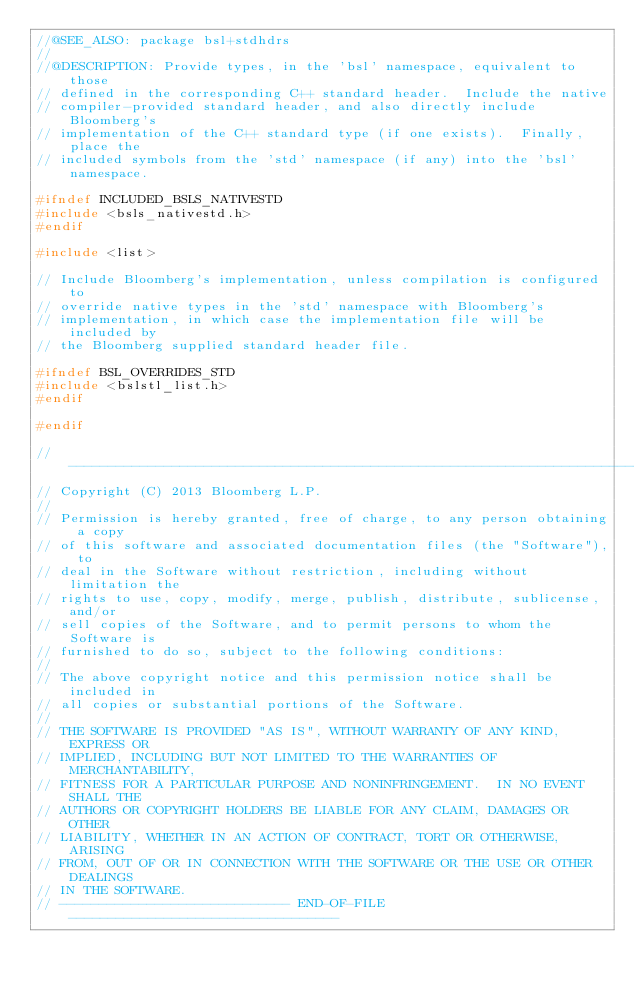<code> <loc_0><loc_0><loc_500><loc_500><_C_>//@SEE_ALSO: package bsl+stdhdrs
//
//@DESCRIPTION: Provide types, in the 'bsl' namespace, equivalent to those
// defined in the corresponding C++ standard header.  Include the native
// compiler-provided standard header, and also directly include Bloomberg's
// implementation of the C++ standard type (if one exists).  Finally, place the
// included symbols from the 'std' namespace (if any) into the 'bsl' namespace.

#ifndef INCLUDED_BSLS_NATIVESTD
#include <bsls_nativestd.h>
#endif

#include <list>

// Include Bloomberg's implementation, unless compilation is configured to
// override native types in the 'std' namespace with Bloomberg's
// implementation, in which case the implementation file will be included by
// the Bloomberg supplied standard header file.

#ifndef BSL_OVERRIDES_STD
#include <bslstl_list.h>
#endif

#endif

// ----------------------------------------------------------------------------
// Copyright (C) 2013 Bloomberg L.P.
//
// Permission is hereby granted, free of charge, to any person obtaining a copy
// of this software and associated documentation files (the "Software"), to
// deal in the Software without restriction, including without limitation the
// rights to use, copy, modify, merge, publish, distribute, sublicense, and/or
// sell copies of the Software, and to permit persons to whom the Software is
// furnished to do so, subject to the following conditions:
//
// The above copyright notice and this permission notice shall be included in
// all copies or substantial portions of the Software.
//
// THE SOFTWARE IS PROVIDED "AS IS", WITHOUT WARRANTY OF ANY KIND, EXPRESS OR
// IMPLIED, INCLUDING BUT NOT LIMITED TO THE WARRANTIES OF MERCHANTABILITY,
// FITNESS FOR A PARTICULAR PURPOSE AND NONINFRINGEMENT.  IN NO EVENT SHALL THE
// AUTHORS OR COPYRIGHT HOLDERS BE LIABLE FOR ANY CLAIM, DAMAGES OR OTHER
// LIABILITY, WHETHER IN AN ACTION OF CONTRACT, TORT OR OTHERWISE, ARISING
// FROM, OUT OF OR IN CONNECTION WITH THE SOFTWARE OR THE USE OR OTHER DEALINGS
// IN THE SOFTWARE.
// ----------------------------- END-OF-FILE ----------------------------------
</code> 